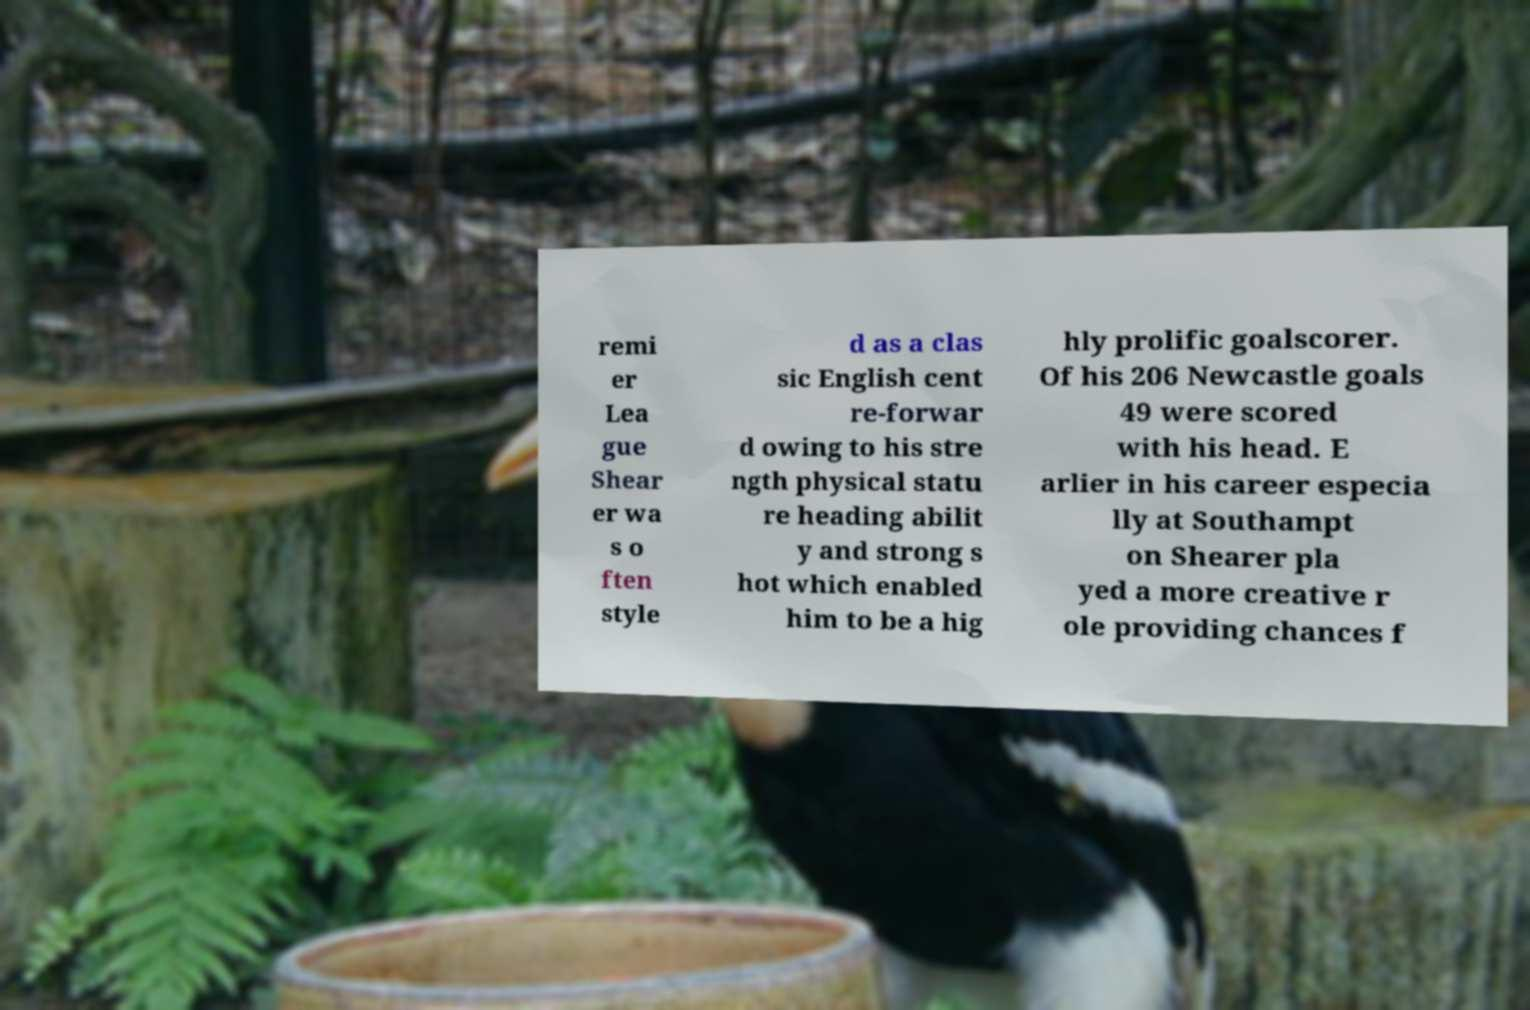Can you read and provide the text displayed in the image?This photo seems to have some interesting text. Can you extract and type it out for me? remi er Lea gue Shear er wa s o ften style d as a clas sic English cent re-forwar d owing to his stre ngth physical statu re heading abilit y and strong s hot which enabled him to be a hig hly prolific goalscorer. Of his 206 Newcastle goals 49 were scored with his head. E arlier in his career especia lly at Southampt on Shearer pla yed a more creative r ole providing chances f 